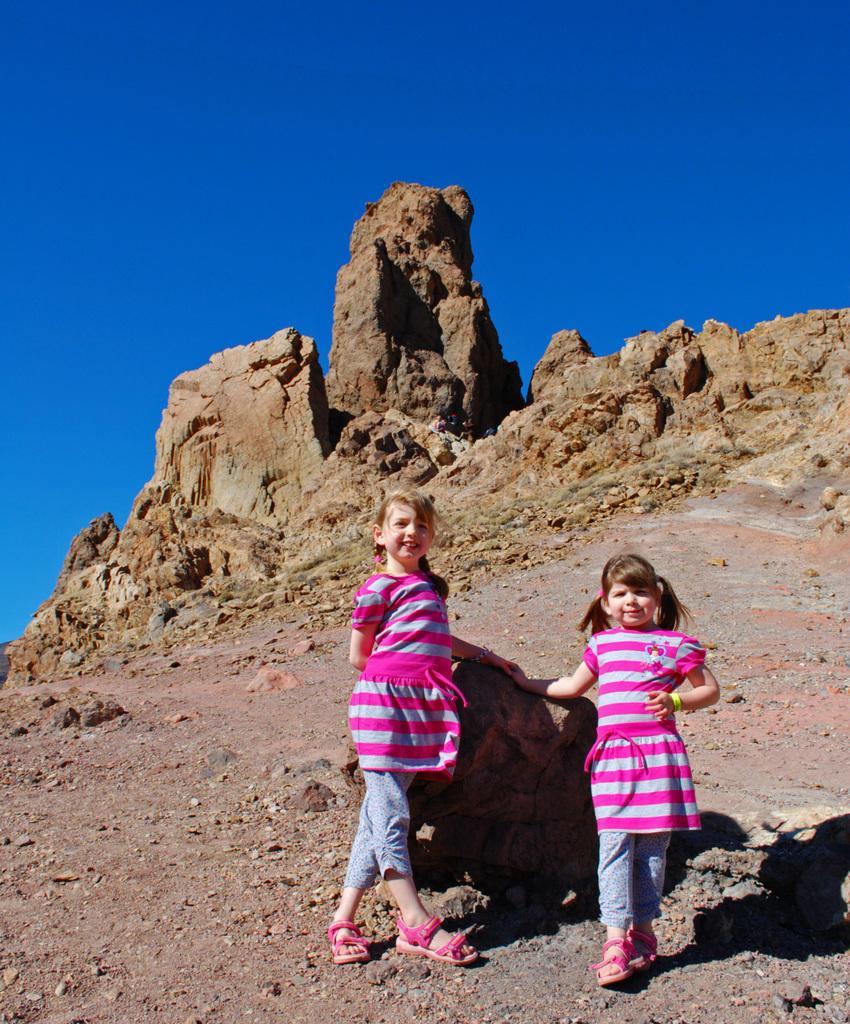How would you summarize this image in a sentence or two? In this image I can see two girls are standing and I can see both of them are wearing pink dress and pink sandals. I can also see shadows, stones and the sky in background. 